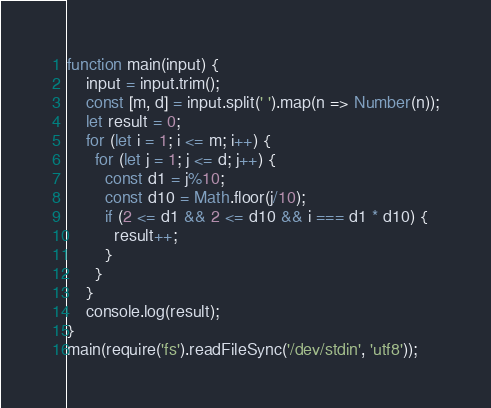<code> <loc_0><loc_0><loc_500><loc_500><_TypeScript_>function main(input) {
	input = input.trim();
  	const [m, d] = input.split(' ').map(n => Number(n));
  	let result = 0;
  	for (let i = 1; i <= m; i++) {
      for (let j = 1; j <= d; j++) {
      	const d1 = j%10;
        const d10 = Math.floor(j/10);
        if (2 <= d1 && 2 <= d10 && i === d1 * d10) {
          result++;
        }
      }
    }
  	console.log(result);
}
main(require('fs').readFileSync('/dev/stdin', 'utf8'));</code> 